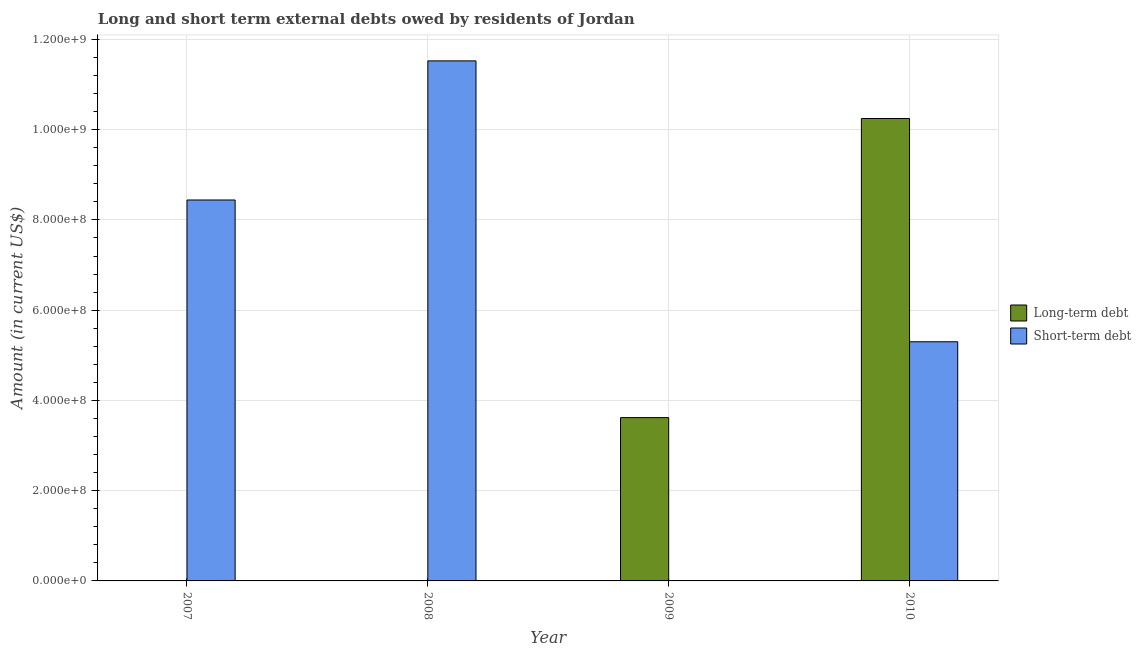How many different coloured bars are there?
Your answer should be compact. 2. How many bars are there on the 3rd tick from the left?
Offer a terse response. 1. In how many cases, is the number of bars for a given year not equal to the number of legend labels?
Keep it short and to the point. 3. What is the short-term debts owed by residents in 2010?
Make the answer very short. 5.30e+08. Across all years, what is the maximum short-term debts owed by residents?
Your answer should be very brief. 1.15e+09. Across all years, what is the minimum short-term debts owed by residents?
Ensure brevity in your answer.  0. In which year was the long-term debts owed by residents maximum?
Offer a very short reply. 2010. What is the total short-term debts owed by residents in the graph?
Give a very brief answer. 2.53e+09. What is the difference between the short-term debts owed by residents in 2007 and that in 2010?
Provide a succinct answer. 3.14e+08. What is the difference between the long-term debts owed by residents in 2009 and the short-term debts owed by residents in 2007?
Offer a very short reply. 3.62e+08. What is the average long-term debts owed by residents per year?
Your response must be concise. 3.47e+08. In the year 2010, what is the difference between the short-term debts owed by residents and long-term debts owed by residents?
Your answer should be compact. 0. In how many years, is the short-term debts owed by residents greater than 840000000 US$?
Give a very brief answer. 2. What is the ratio of the short-term debts owed by residents in 2007 to that in 2008?
Provide a short and direct response. 0.73. What is the difference between the highest and the second highest short-term debts owed by residents?
Offer a very short reply. 3.08e+08. What is the difference between the highest and the lowest short-term debts owed by residents?
Your answer should be compact. 1.15e+09. In how many years, is the short-term debts owed by residents greater than the average short-term debts owed by residents taken over all years?
Offer a very short reply. 2. Is the sum of the short-term debts owed by residents in 2007 and 2008 greater than the maximum long-term debts owed by residents across all years?
Offer a terse response. Yes. How many years are there in the graph?
Keep it short and to the point. 4. Does the graph contain grids?
Your response must be concise. Yes. Where does the legend appear in the graph?
Your answer should be very brief. Center right. How many legend labels are there?
Your response must be concise. 2. How are the legend labels stacked?
Keep it short and to the point. Vertical. What is the title of the graph?
Make the answer very short. Long and short term external debts owed by residents of Jordan. Does "Attending school" appear as one of the legend labels in the graph?
Your response must be concise. No. What is the label or title of the Y-axis?
Give a very brief answer. Amount (in current US$). What is the Amount (in current US$) in Long-term debt in 2007?
Offer a very short reply. 0. What is the Amount (in current US$) in Short-term debt in 2007?
Your answer should be compact. 8.44e+08. What is the Amount (in current US$) of Long-term debt in 2008?
Provide a succinct answer. 0. What is the Amount (in current US$) of Short-term debt in 2008?
Offer a very short reply. 1.15e+09. What is the Amount (in current US$) of Long-term debt in 2009?
Give a very brief answer. 3.62e+08. What is the Amount (in current US$) in Short-term debt in 2009?
Make the answer very short. 0. What is the Amount (in current US$) of Long-term debt in 2010?
Offer a terse response. 1.02e+09. What is the Amount (in current US$) of Short-term debt in 2010?
Offer a terse response. 5.30e+08. Across all years, what is the maximum Amount (in current US$) in Long-term debt?
Offer a very short reply. 1.02e+09. Across all years, what is the maximum Amount (in current US$) in Short-term debt?
Give a very brief answer. 1.15e+09. What is the total Amount (in current US$) of Long-term debt in the graph?
Your answer should be compact. 1.39e+09. What is the total Amount (in current US$) in Short-term debt in the graph?
Offer a very short reply. 2.53e+09. What is the difference between the Amount (in current US$) of Short-term debt in 2007 and that in 2008?
Make the answer very short. -3.08e+08. What is the difference between the Amount (in current US$) in Short-term debt in 2007 and that in 2010?
Your answer should be very brief. 3.14e+08. What is the difference between the Amount (in current US$) of Short-term debt in 2008 and that in 2010?
Make the answer very short. 6.22e+08. What is the difference between the Amount (in current US$) in Long-term debt in 2009 and that in 2010?
Offer a very short reply. -6.63e+08. What is the difference between the Amount (in current US$) in Long-term debt in 2009 and the Amount (in current US$) in Short-term debt in 2010?
Your response must be concise. -1.68e+08. What is the average Amount (in current US$) of Long-term debt per year?
Provide a short and direct response. 3.47e+08. What is the average Amount (in current US$) of Short-term debt per year?
Offer a terse response. 6.32e+08. In the year 2010, what is the difference between the Amount (in current US$) of Long-term debt and Amount (in current US$) of Short-term debt?
Your answer should be very brief. 4.95e+08. What is the ratio of the Amount (in current US$) of Short-term debt in 2007 to that in 2008?
Ensure brevity in your answer.  0.73. What is the ratio of the Amount (in current US$) of Short-term debt in 2007 to that in 2010?
Offer a very short reply. 1.59. What is the ratio of the Amount (in current US$) in Short-term debt in 2008 to that in 2010?
Your answer should be very brief. 2.17. What is the ratio of the Amount (in current US$) in Long-term debt in 2009 to that in 2010?
Your response must be concise. 0.35. What is the difference between the highest and the second highest Amount (in current US$) in Short-term debt?
Offer a terse response. 3.08e+08. What is the difference between the highest and the lowest Amount (in current US$) in Long-term debt?
Keep it short and to the point. 1.02e+09. What is the difference between the highest and the lowest Amount (in current US$) of Short-term debt?
Keep it short and to the point. 1.15e+09. 